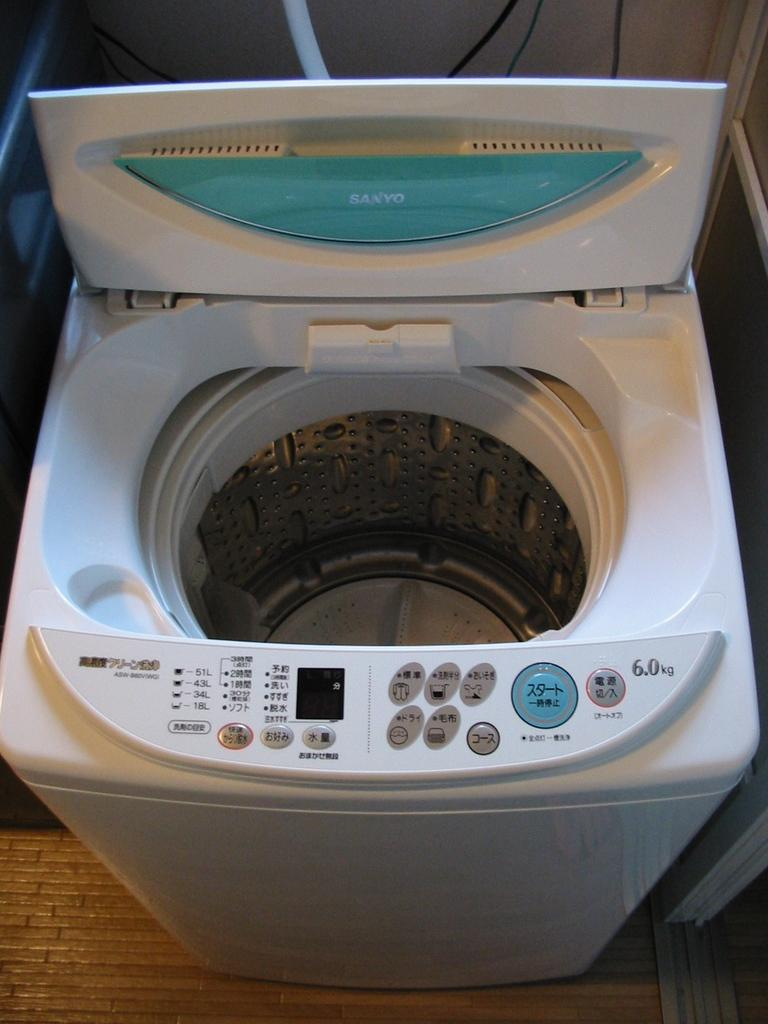What type of appliance is present in the image? There is a washing machine in the image. What is the color of the washing machine? The washing machine is white in color. What feature is present on the washing machine for controlling its functions? There are buttons on the washing machine. Is there a crown placed on top of the washing machine in the image? No, there is no crown present on top of the washing machine in the image. What hobbies does the washing machine have in the image? Washing machines do not have hobbies, as they are inanimate objects. 